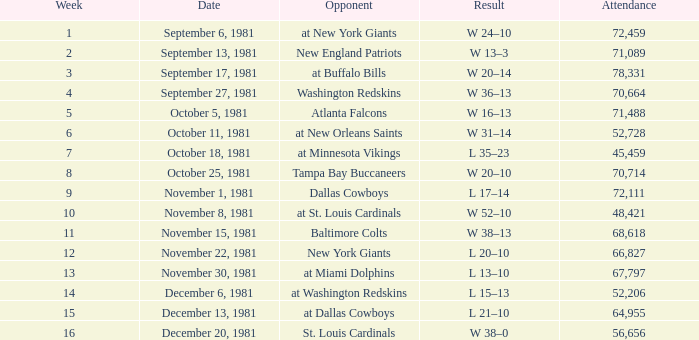What is the Attendance, when the Opponent is the Tampa Bay Buccaneers? 70714.0. 